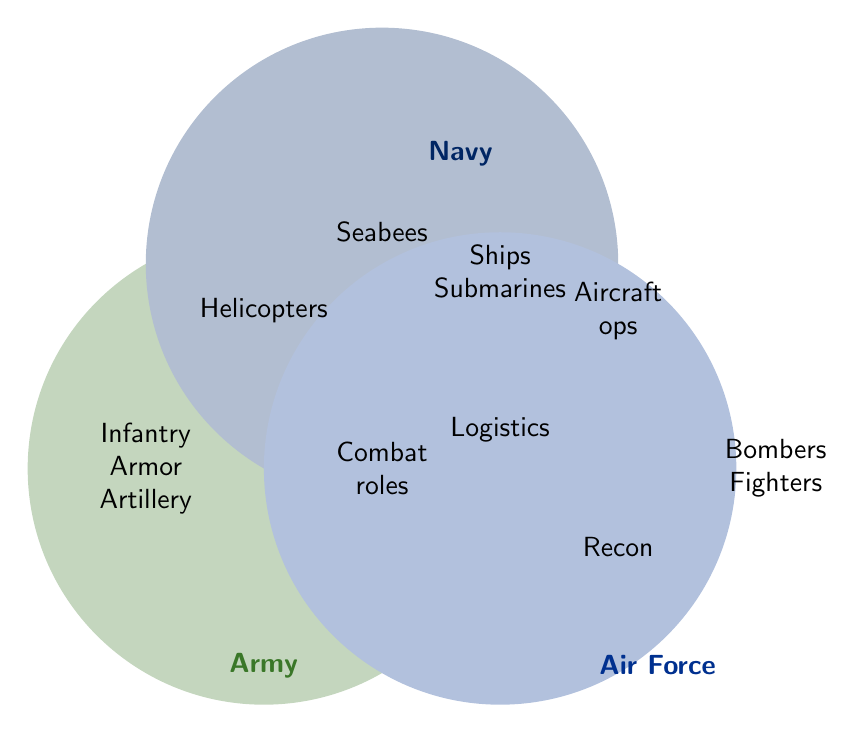What are the overlapping roles between the Army and Navy? The shared section between the Army and Navy circles includes the term "Combat roles" indicating that this is a role common to both.
Answer: Combat roles Which branch has Infantry? Infantry is listed within the section for the Army.
Answer: Army Are there any roles exclusive to the Air Force? The Air Force has unique roles listed within its circle without overlap with others, such as Bombers and Fighters.
Answer: Bombers, Fighters How many branches engage in Logistics? The term "Logistics" is in the overlapping area between all three circles, indicating that Logistics is a role shared by the Army, Navy, and Air Force.
Answer: 3 Are there any shared roles between the Navy and Air Force that are not shared with the Army? The diagram shows that Aircraft operations is a role shared between the Navy and Air Force without including the Army.
Answer: Aircraft operations What military branch is associated with Seabees? Seabees is listed solely within the circle of the Navy.
Answer: Navy How many unique roles does the Army have, not shared with other branches? The Army has unique roles listed: Infantry, Armor, Artillery, and Helicopters. This gives a total of 4 unique roles.
Answer: 4 Which military branch involves Reconnaissance? Reconnaissance is listed within the Air Force's area.
Answer: Air Force Is "Combat roles" associated with more than one branch? Yes, "Combat roles" is listed within the overlapping section of the Army, Navy, and Air Force circles.
Answer: Yes Are submarines part of the Air Force roles? Submarines is listed within the Navy circle, not the Air Force circle.
Answer: No 